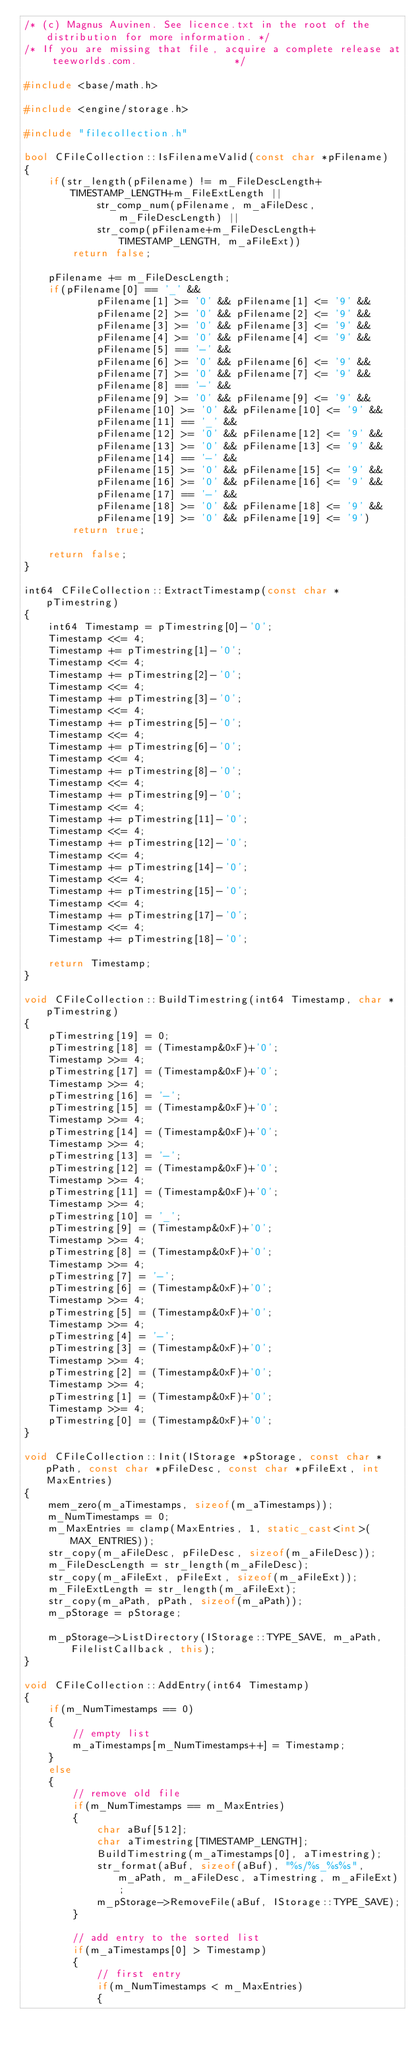<code> <loc_0><loc_0><loc_500><loc_500><_C++_>/* (c) Magnus Auvinen. See licence.txt in the root of the distribution for more information. */
/* If you are missing that file, acquire a complete release at teeworlds.com.                */

#include <base/math.h>

#include <engine/storage.h>

#include "filecollection.h"

bool CFileCollection::IsFilenameValid(const char *pFilename)
{
    if(str_length(pFilename) != m_FileDescLength+TIMESTAMP_LENGTH+m_FileExtLength ||
            str_comp_num(pFilename, m_aFileDesc, m_FileDescLength) ||
            str_comp(pFilename+m_FileDescLength+TIMESTAMP_LENGTH, m_aFileExt))
        return false;

    pFilename += m_FileDescLength;
    if(pFilename[0] == '_' &&
            pFilename[1] >= '0' && pFilename[1] <= '9' &&
            pFilename[2] >= '0' && pFilename[2] <= '9' &&
            pFilename[3] >= '0' && pFilename[3] <= '9' &&
            pFilename[4] >= '0' && pFilename[4] <= '9' &&
            pFilename[5] == '-' &&
            pFilename[6] >= '0' && pFilename[6] <= '9' &&
            pFilename[7] >= '0' && pFilename[7] <= '9' &&
            pFilename[8] == '-' &&
            pFilename[9] >= '0' && pFilename[9] <= '9' &&
            pFilename[10] >= '0' && pFilename[10] <= '9' &&
            pFilename[11] == '_' &&
            pFilename[12] >= '0' && pFilename[12] <= '9' &&
            pFilename[13] >= '0' && pFilename[13] <= '9' &&
            pFilename[14] == '-' &&
            pFilename[15] >= '0' && pFilename[15] <= '9' &&
            pFilename[16] >= '0' && pFilename[16] <= '9' &&
            pFilename[17] == '-' &&
            pFilename[18] >= '0' && pFilename[18] <= '9' &&
            pFilename[19] >= '0' && pFilename[19] <= '9')
        return true;

    return false;
}

int64 CFileCollection::ExtractTimestamp(const char *pTimestring)
{
    int64 Timestamp = pTimestring[0]-'0';
    Timestamp <<= 4;
    Timestamp += pTimestring[1]-'0';
    Timestamp <<= 4;
    Timestamp += pTimestring[2]-'0';
    Timestamp <<= 4;
    Timestamp += pTimestring[3]-'0';
    Timestamp <<= 4;
    Timestamp += pTimestring[5]-'0';
    Timestamp <<= 4;
    Timestamp += pTimestring[6]-'0';
    Timestamp <<= 4;
    Timestamp += pTimestring[8]-'0';
    Timestamp <<= 4;
    Timestamp += pTimestring[9]-'0';
    Timestamp <<= 4;
    Timestamp += pTimestring[11]-'0';
    Timestamp <<= 4;
    Timestamp += pTimestring[12]-'0';
    Timestamp <<= 4;
    Timestamp += pTimestring[14]-'0';
    Timestamp <<= 4;
    Timestamp += pTimestring[15]-'0';
    Timestamp <<= 4;
    Timestamp += pTimestring[17]-'0';
    Timestamp <<= 4;
    Timestamp += pTimestring[18]-'0';

    return Timestamp;
}

void CFileCollection::BuildTimestring(int64 Timestamp, char *pTimestring)
{
    pTimestring[19] = 0;
    pTimestring[18] = (Timestamp&0xF)+'0';
    Timestamp >>= 4;
    pTimestring[17] = (Timestamp&0xF)+'0';
    Timestamp >>= 4;
    pTimestring[16] = '-';
    pTimestring[15] = (Timestamp&0xF)+'0';
    Timestamp >>= 4;
    pTimestring[14] = (Timestamp&0xF)+'0';
    Timestamp >>= 4;
    pTimestring[13] = '-';
    pTimestring[12] = (Timestamp&0xF)+'0';
    Timestamp >>= 4;
    pTimestring[11] = (Timestamp&0xF)+'0';
    Timestamp >>= 4;
    pTimestring[10] = '_';
    pTimestring[9] = (Timestamp&0xF)+'0';
    Timestamp >>= 4;
    pTimestring[8] = (Timestamp&0xF)+'0';
    Timestamp >>= 4;
    pTimestring[7] = '-';
    pTimestring[6] = (Timestamp&0xF)+'0';
    Timestamp >>= 4;
    pTimestring[5] = (Timestamp&0xF)+'0';
    Timestamp >>= 4;
    pTimestring[4] = '-';
    pTimestring[3] = (Timestamp&0xF)+'0';
    Timestamp >>= 4;
    pTimestring[2] = (Timestamp&0xF)+'0';
    Timestamp >>= 4;
    pTimestring[1] = (Timestamp&0xF)+'0';
    Timestamp >>= 4;
    pTimestring[0] = (Timestamp&0xF)+'0';
}

void CFileCollection::Init(IStorage *pStorage, const char *pPath, const char *pFileDesc, const char *pFileExt, int MaxEntries)
{
    mem_zero(m_aTimestamps, sizeof(m_aTimestamps));
    m_NumTimestamps = 0;
    m_MaxEntries = clamp(MaxEntries, 1, static_cast<int>(MAX_ENTRIES));
    str_copy(m_aFileDesc, pFileDesc, sizeof(m_aFileDesc));
    m_FileDescLength = str_length(m_aFileDesc);
    str_copy(m_aFileExt, pFileExt, sizeof(m_aFileExt));
    m_FileExtLength = str_length(m_aFileExt);
    str_copy(m_aPath, pPath, sizeof(m_aPath));
    m_pStorage = pStorage;

    m_pStorage->ListDirectory(IStorage::TYPE_SAVE, m_aPath, FilelistCallback, this);
}

void CFileCollection::AddEntry(int64 Timestamp)
{
    if(m_NumTimestamps == 0)
    {
        // empty list
        m_aTimestamps[m_NumTimestamps++] = Timestamp;
    }
    else
    {
        // remove old file
        if(m_NumTimestamps == m_MaxEntries)
        {
            char aBuf[512];
            char aTimestring[TIMESTAMP_LENGTH];
            BuildTimestring(m_aTimestamps[0], aTimestring);
            str_format(aBuf, sizeof(aBuf), "%s/%s_%s%s", m_aPath, m_aFileDesc, aTimestring, m_aFileExt);
            m_pStorage->RemoveFile(aBuf, IStorage::TYPE_SAVE);
        }

        // add entry to the sorted list
        if(m_aTimestamps[0] > Timestamp)
        {
            // first entry
            if(m_NumTimestamps < m_MaxEntries)
            {</code> 